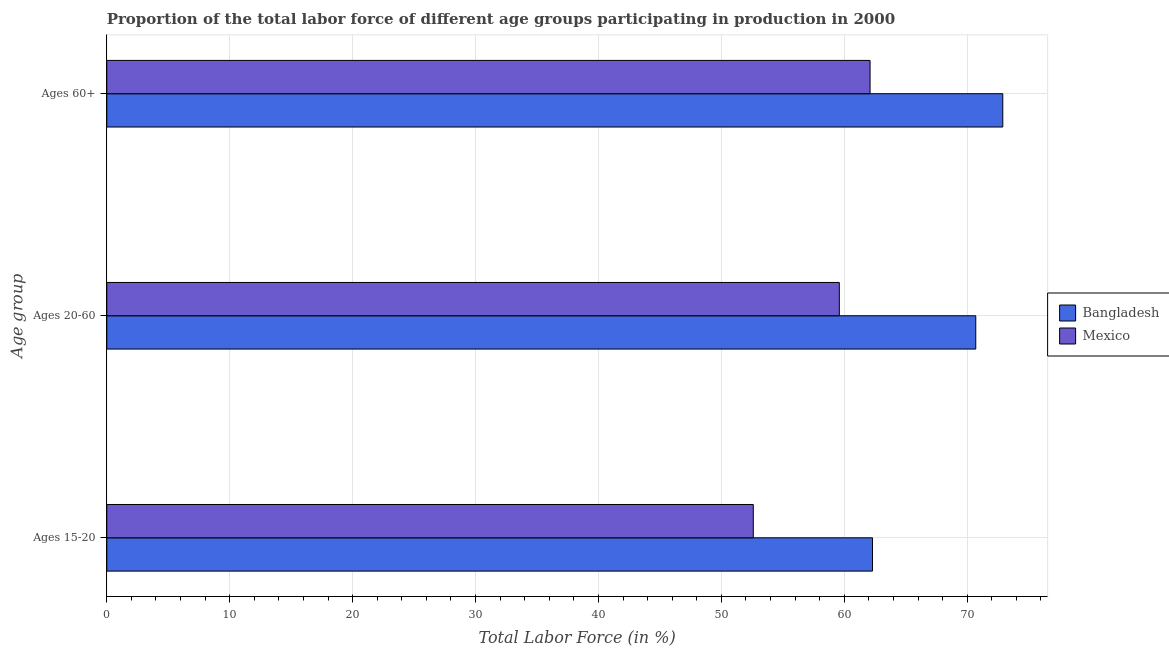How many bars are there on the 3rd tick from the top?
Give a very brief answer. 2. How many bars are there on the 3rd tick from the bottom?
Your answer should be very brief. 2. What is the label of the 1st group of bars from the top?
Provide a succinct answer. Ages 60+. What is the percentage of labor force within the age group 20-60 in Bangladesh?
Offer a terse response. 70.7. Across all countries, what is the maximum percentage of labor force within the age group 15-20?
Ensure brevity in your answer.  62.3. Across all countries, what is the minimum percentage of labor force within the age group 20-60?
Offer a terse response. 59.6. What is the total percentage of labor force within the age group 20-60 in the graph?
Ensure brevity in your answer.  130.3. What is the difference between the percentage of labor force above age 60 in Mexico and that in Bangladesh?
Ensure brevity in your answer.  -10.8. What is the difference between the percentage of labor force within the age group 15-20 in Bangladesh and the percentage of labor force within the age group 20-60 in Mexico?
Your answer should be very brief. 2.7. What is the average percentage of labor force within the age group 20-60 per country?
Offer a terse response. 65.15. What is the difference between the percentage of labor force within the age group 15-20 and percentage of labor force within the age group 20-60 in Bangladesh?
Make the answer very short. -8.4. What is the ratio of the percentage of labor force above age 60 in Bangladesh to that in Mexico?
Make the answer very short. 1.17. Is the percentage of labor force above age 60 in Mexico less than that in Bangladesh?
Offer a terse response. Yes. Is the difference between the percentage of labor force above age 60 in Bangladesh and Mexico greater than the difference between the percentage of labor force within the age group 15-20 in Bangladesh and Mexico?
Provide a succinct answer. Yes. What is the difference between the highest and the second highest percentage of labor force within the age group 15-20?
Offer a terse response. 9.7. What is the difference between the highest and the lowest percentage of labor force within the age group 20-60?
Ensure brevity in your answer.  11.1. In how many countries, is the percentage of labor force within the age group 20-60 greater than the average percentage of labor force within the age group 20-60 taken over all countries?
Provide a short and direct response. 1. What does the 2nd bar from the bottom in Ages 20-60 represents?
Offer a very short reply. Mexico. What is the difference between two consecutive major ticks on the X-axis?
Give a very brief answer. 10. Where does the legend appear in the graph?
Your answer should be very brief. Center right. How many legend labels are there?
Offer a terse response. 2. What is the title of the graph?
Give a very brief answer. Proportion of the total labor force of different age groups participating in production in 2000. What is the label or title of the X-axis?
Give a very brief answer. Total Labor Force (in %). What is the label or title of the Y-axis?
Offer a terse response. Age group. What is the Total Labor Force (in %) of Bangladesh in Ages 15-20?
Ensure brevity in your answer.  62.3. What is the Total Labor Force (in %) of Mexico in Ages 15-20?
Provide a succinct answer. 52.6. What is the Total Labor Force (in %) of Bangladesh in Ages 20-60?
Your answer should be compact. 70.7. What is the Total Labor Force (in %) of Mexico in Ages 20-60?
Provide a succinct answer. 59.6. What is the Total Labor Force (in %) in Bangladesh in Ages 60+?
Offer a terse response. 72.9. What is the Total Labor Force (in %) in Mexico in Ages 60+?
Make the answer very short. 62.1. Across all Age group, what is the maximum Total Labor Force (in %) in Bangladesh?
Give a very brief answer. 72.9. Across all Age group, what is the maximum Total Labor Force (in %) in Mexico?
Your response must be concise. 62.1. Across all Age group, what is the minimum Total Labor Force (in %) in Bangladesh?
Make the answer very short. 62.3. Across all Age group, what is the minimum Total Labor Force (in %) of Mexico?
Ensure brevity in your answer.  52.6. What is the total Total Labor Force (in %) of Bangladesh in the graph?
Give a very brief answer. 205.9. What is the total Total Labor Force (in %) of Mexico in the graph?
Your answer should be very brief. 174.3. What is the difference between the Total Labor Force (in %) of Bangladesh in Ages 15-20 and that in Ages 20-60?
Provide a succinct answer. -8.4. What is the difference between the Total Labor Force (in %) in Mexico in Ages 15-20 and that in Ages 20-60?
Keep it short and to the point. -7. What is the difference between the Total Labor Force (in %) of Bangladesh in Ages 15-20 and that in Ages 60+?
Your answer should be very brief. -10.6. What is the difference between the Total Labor Force (in %) in Mexico in Ages 15-20 and that in Ages 60+?
Make the answer very short. -9.5. What is the difference between the Total Labor Force (in %) of Mexico in Ages 20-60 and that in Ages 60+?
Give a very brief answer. -2.5. What is the difference between the Total Labor Force (in %) of Bangladesh in Ages 15-20 and the Total Labor Force (in %) of Mexico in Ages 60+?
Ensure brevity in your answer.  0.2. What is the difference between the Total Labor Force (in %) in Bangladesh in Ages 20-60 and the Total Labor Force (in %) in Mexico in Ages 60+?
Your response must be concise. 8.6. What is the average Total Labor Force (in %) in Bangladesh per Age group?
Your answer should be compact. 68.63. What is the average Total Labor Force (in %) of Mexico per Age group?
Offer a terse response. 58.1. What is the difference between the Total Labor Force (in %) of Bangladesh and Total Labor Force (in %) of Mexico in Ages 15-20?
Offer a terse response. 9.7. What is the difference between the Total Labor Force (in %) of Bangladesh and Total Labor Force (in %) of Mexico in Ages 20-60?
Provide a short and direct response. 11.1. What is the difference between the Total Labor Force (in %) of Bangladesh and Total Labor Force (in %) of Mexico in Ages 60+?
Your response must be concise. 10.8. What is the ratio of the Total Labor Force (in %) in Bangladesh in Ages 15-20 to that in Ages 20-60?
Make the answer very short. 0.88. What is the ratio of the Total Labor Force (in %) in Mexico in Ages 15-20 to that in Ages 20-60?
Provide a succinct answer. 0.88. What is the ratio of the Total Labor Force (in %) in Bangladesh in Ages 15-20 to that in Ages 60+?
Make the answer very short. 0.85. What is the ratio of the Total Labor Force (in %) in Mexico in Ages 15-20 to that in Ages 60+?
Provide a succinct answer. 0.85. What is the ratio of the Total Labor Force (in %) in Bangladesh in Ages 20-60 to that in Ages 60+?
Give a very brief answer. 0.97. What is the ratio of the Total Labor Force (in %) of Mexico in Ages 20-60 to that in Ages 60+?
Give a very brief answer. 0.96. What is the difference between the highest and the second highest Total Labor Force (in %) in Mexico?
Provide a short and direct response. 2.5. What is the difference between the highest and the lowest Total Labor Force (in %) in Bangladesh?
Your answer should be very brief. 10.6. 